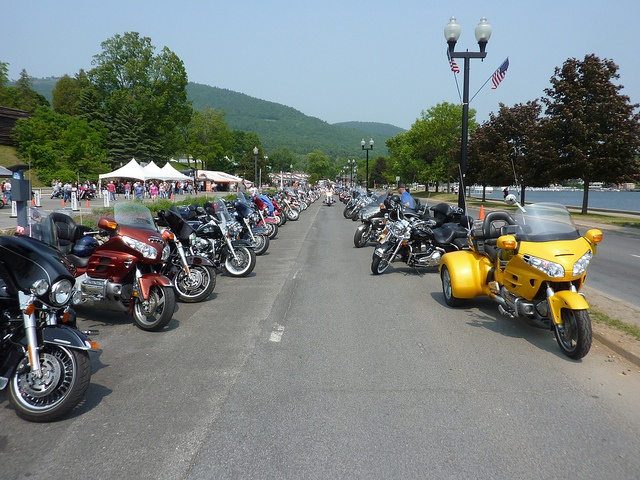Describe the objects in this image and their specific colors. I can see motorcycle in lightblue, black, gray, darkgray, and olive tones, motorcycle in lightblue, black, gray, and darkgray tones, motorcycle in lightblue, black, gray, darkgray, and maroon tones, motorcycle in lightblue, black, gray, darkgray, and lightgray tones, and motorcycle in lightblue, black, gray, darkgray, and lightgray tones in this image. 